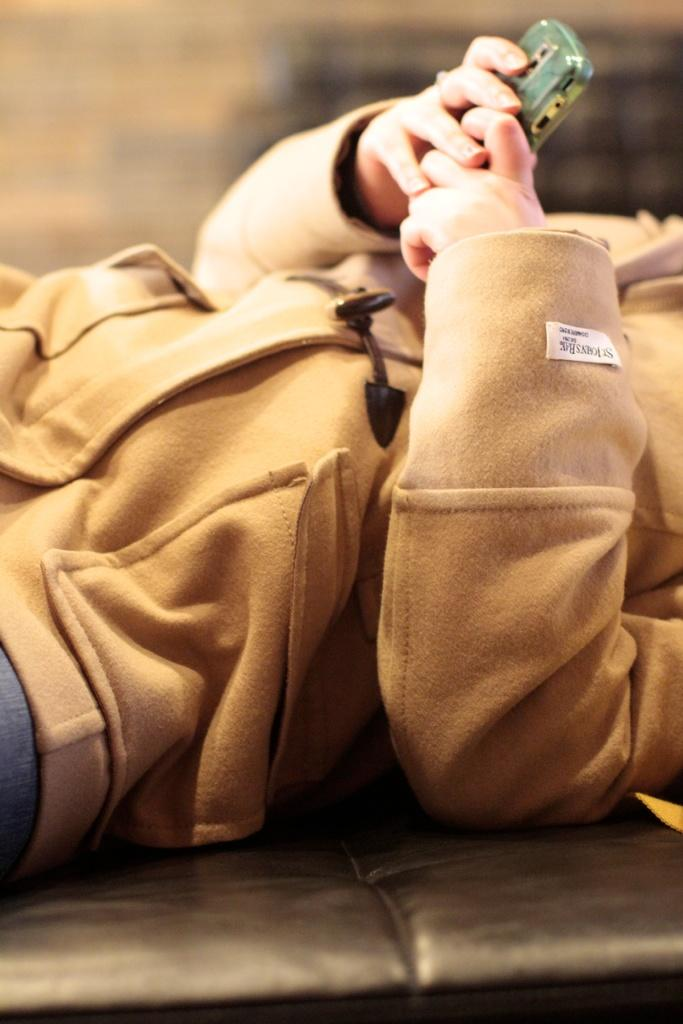What is the main subject of the image? There is a person in the image. What is the person wearing? The person is wearing a jacket. What object is the person holding? The person is holding a mobile. What is the person's position in the image? The person is lying on a surface. How would you describe the background of the image? The background of the image is blurred. How does the wind affect the person's thoughts in the image? There is no mention of wind or thoughts in the image, so it is not possible to answer this question. 